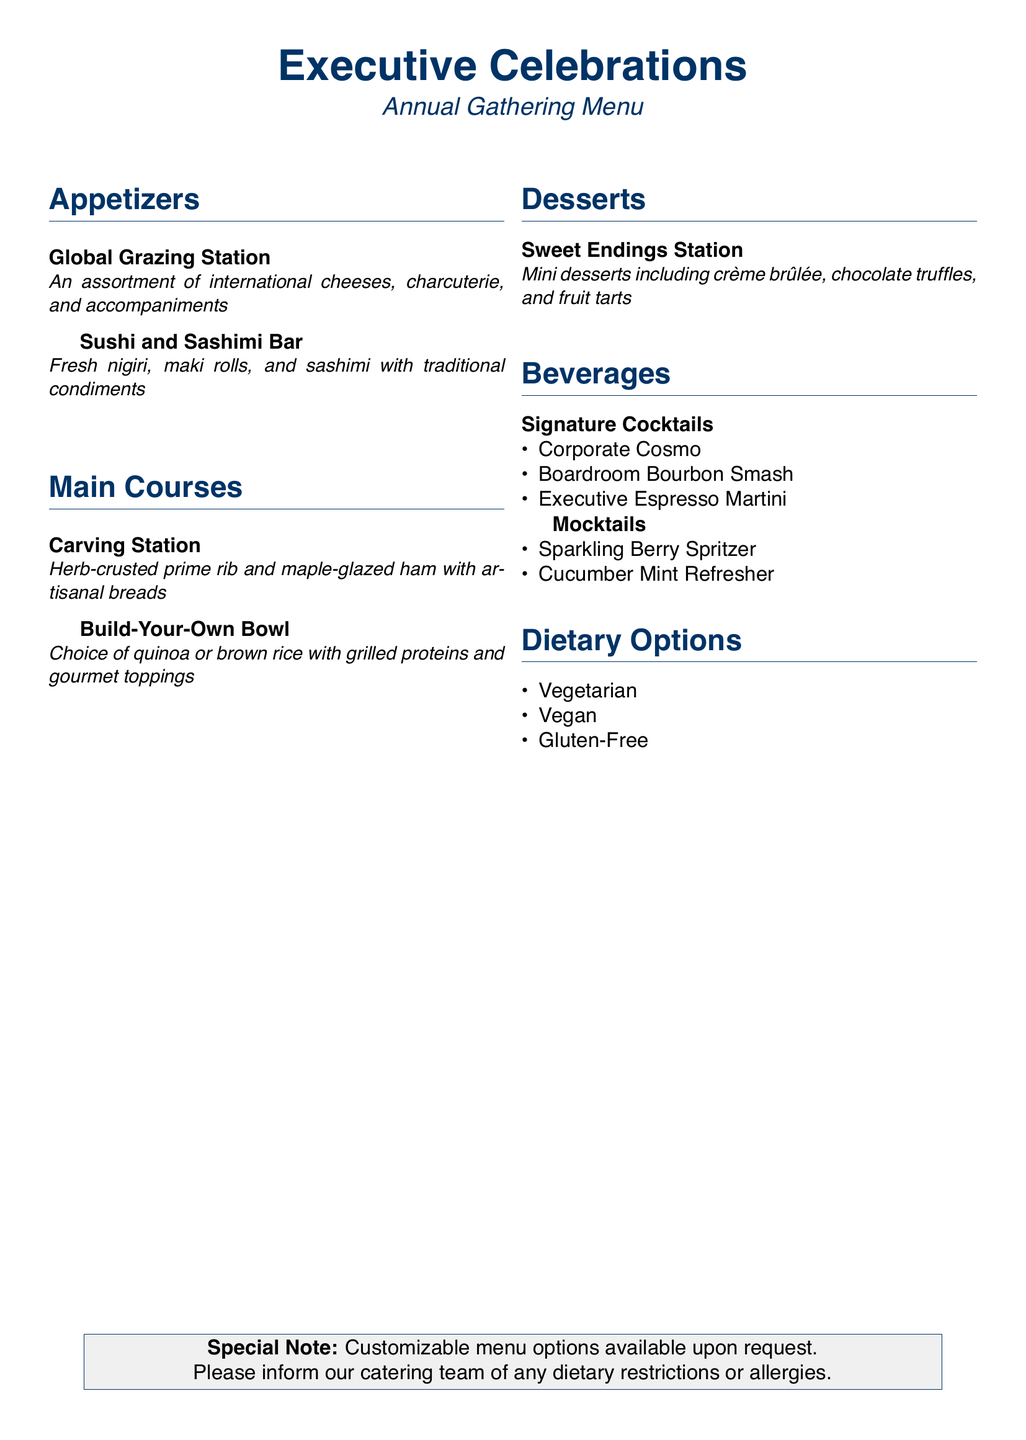What is the title of the document? The title of the document is located at the top and describes the menu theme for the event.
Answer: Executive Celebrations How many appetizer options are offered? By counting the listed appetizer menu items, we can identify the total number.
Answer: 2 What is the main item at the Carving Station? The document specifies the main offerings at the Carving Station within the main courses section.
Answer: Herb-crusted prime rib What is included in the Sweet Endings Station? The description under the desserts section lists the types of mini desserts available.
Answer: Mini desserts What are the three signature cocktails mentioned? The beverages section lists specific cocktail options under the signature cocktails category.
Answer: Corporate Cosmo, Boardroom Bourbon Smash, Executive Espresso Martini What dietary options are available? The document lists specific dietary options under the dietary options section.
Answer: Vegetarian, Vegan, Gluten-Free Is there a customization option for the menu? A special note is provided in the bottom section regarding the menu's flexibility.
Answer: Customizable menu options What two main bases can be chosen for the Build-Your-Own Bowl? The description of the Build-Your-Own Bowl specifies the two base choices available.
Answer: Quinoa or brown rice 